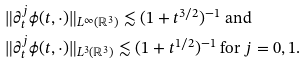<formula> <loc_0><loc_0><loc_500><loc_500>& \| \partial _ { t } ^ { j } \phi ( t , \cdot ) \| _ { L ^ { \infty } ( \mathbb { R } ^ { 3 } ) } \lesssim ( 1 + t ^ { 3 / 2 } ) ^ { - 1 } \text { and } \\ & \| \partial _ { t } ^ { j } \phi ( t , \cdot ) \| _ { L ^ { 3 } ( \mathbb { R } ^ { 3 } ) } \lesssim ( 1 + t ^ { 1 / 2 } ) ^ { - 1 } \text { for } j = 0 , 1 .</formula> 